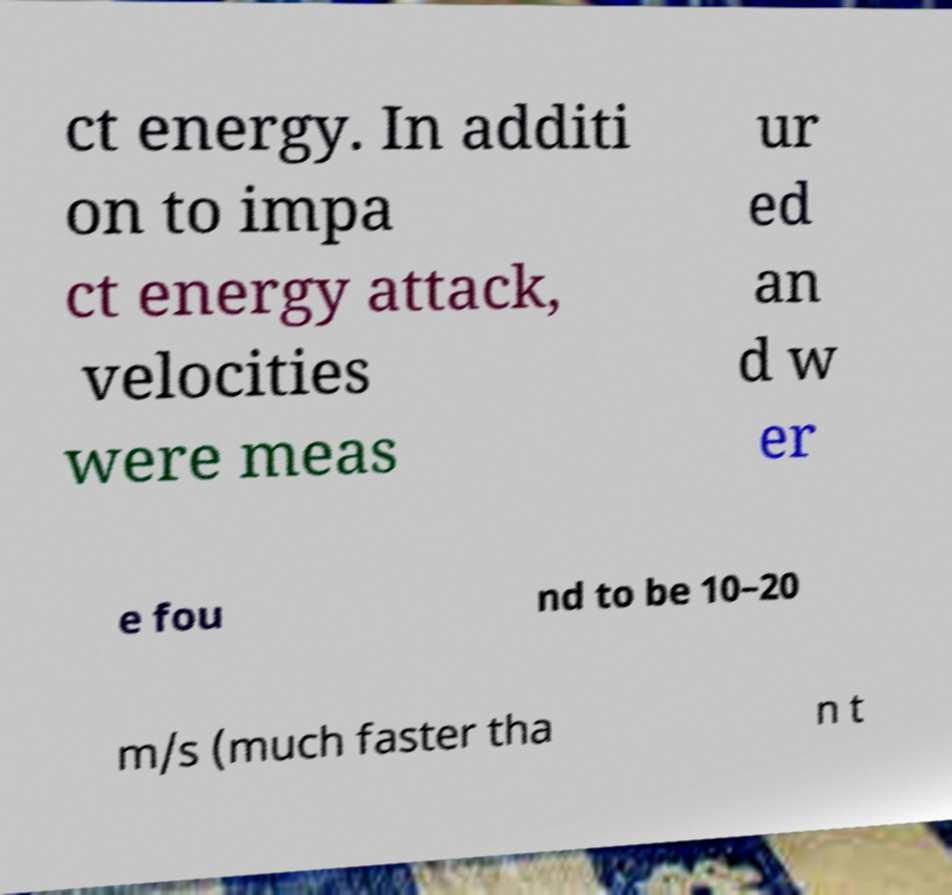There's text embedded in this image that I need extracted. Can you transcribe it verbatim? ct energy. In additi on to impa ct energy attack, velocities were meas ur ed an d w er e fou nd to be 10–20 m/s (much faster tha n t 